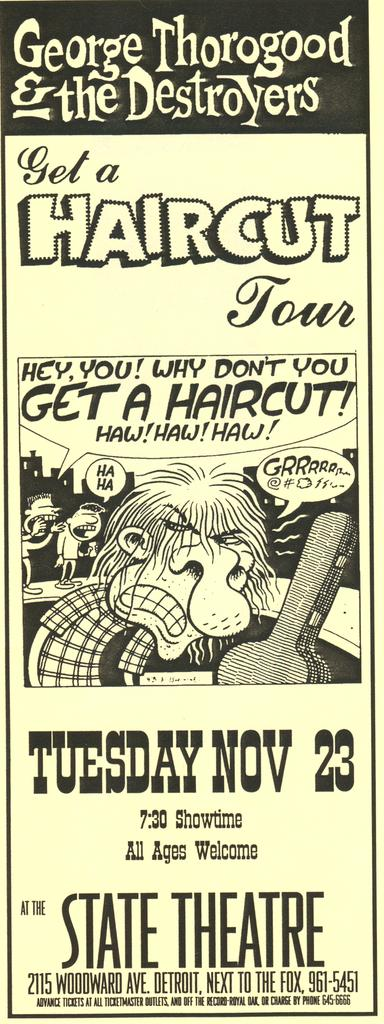<image>
Offer a succinct explanation of the picture presented. Tickets for the George Thorogood & the Destroyers concert say that it will be held Tuesday, November 23 at 7:30. 